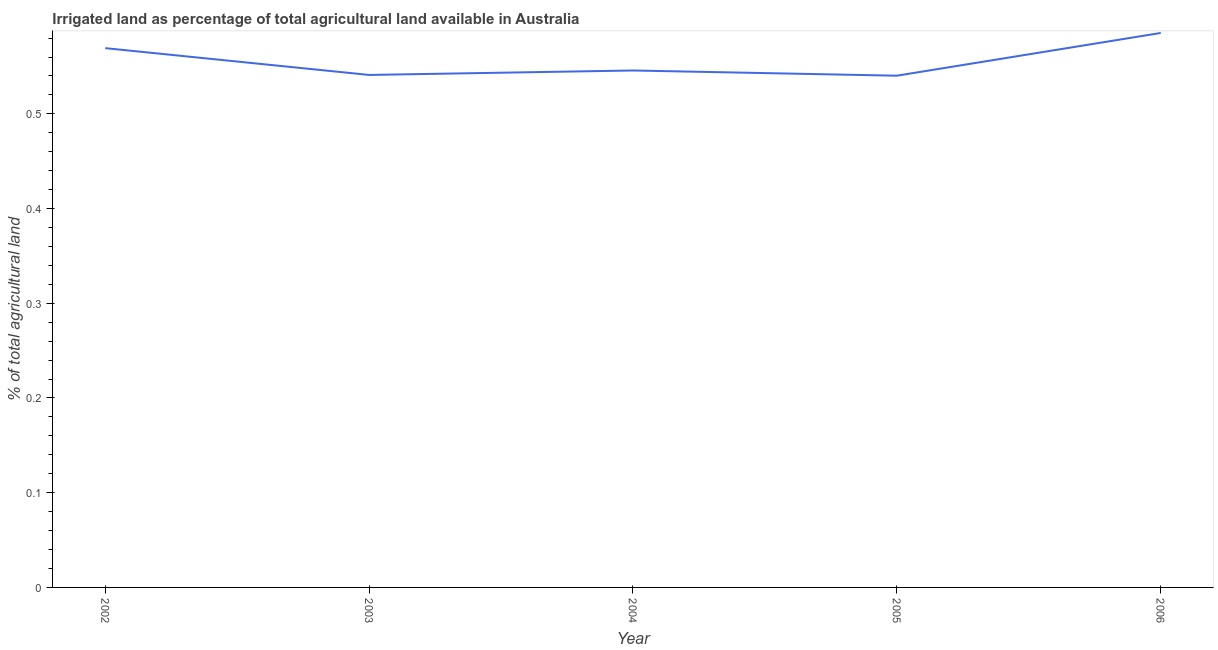What is the percentage of agricultural irrigated land in 2005?
Provide a short and direct response. 0.54. Across all years, what is the maximum percentage of agricultural irrigated land?
Keep it short and to the point. 0.59. Across all years, what is the minimum percentage of agricultural irrigated land?
Make the answer very short. 0.54. In which year was the percentage of agricultural irrigated land maximum?
Make the answer very short. 2006. What is the sum of the percentage of agricultural irrigated land?
Give a very brief answer. 2.78. What is the difference between the percentage of agricultural irrigated land in 2002 and 2005?
Offer a very short reply. 0.03. What is the average percentage of agricultural irrigated land per year?
Your response must be concise. 0.56. What is the median percentage of agricultural irrigated land?
Provide a short and direct response. 0.55. In how many years, is the percentage of agricultural irrigated land greater than 0.30000000000000004 %?
Your answer should be very brief. 5. Do a majority of the years between 2004 and 2002 (inclusive) have percentage of agricultural irrigated land greater than 0.06 %?
Your answer should be compact. No. What is the ratio of the percentage of agricultural irrigated land in 2003 to that in 2006?
Offer a terse response. 0.92. Is the difference between the percentage of agricultural irrigated land in 2005 and 2006 greater than the difference between any two years?
Keep it short and to the point. Yes. What is the difference between the highest and the second highest percentage of agricultural irrigated land?
Provide a short and direct response. 0.02. What is the difference between the highest and the lowest percentage of agricultural irrigated land?
Provide a succinct answer. 0.05. In how many years, is the percentage of agricultural irrigated land greater than the average percentage of agricultural irrigated land taken over all years?
Ensure brevity in your answer.  2. How many lines are there?
Offer a terse response. 1. Does the graph contain any zero values?
Your answer should be very brief. No. Does the graph contain grids?
Provide a succinct answer. No. What is the title of the graph?
Ensure brevity in your answer.  Irrigated land as percentage of total agricultural land available in Australia. What is the label or title of the Y-axis?
Provide a short and direct response. % of total agricultural land. What is the % of total agricultural land in 2002?
Your answer should be very brief. 0.57. What is the % of total agricultural land of 2003?
Give a very brief answer. 0.54. What is the % of total agricultural land of 2004?
Your answer should be very brief. 0.55. What is the % of total agricultural land of 2005?
Provide a short and direct response. 0.54. What is the % of total agricultural land of 2006?
Your answer should be very brief. 0.59. What is the difference between the % of total agricultural land in 2002 and 2003?
Offer a very short reply. 0.03. What is the difference between the % of total agricultural land in 2002 and 2004?
Give a very brief answer. 0.02. What is the difference between the % of total agricultural land in 2002 and 2005?
Your answer should be compact. 0.03. What is the difference between the % of total agricultural land in 2002 and 2006?
Your answer should be very brief. -0.02. What is the difference between the % of total agricultural land in 2003 and 2004?
Keep it short and to the point. -0. What is the difference between the % of total agricultural land in 2003 and 2005?
Ensure brevity in your answer.  0. What is the difference between the % of total agricultural land in 2003 and 2006?
Offer a terse response. -0.04. What is the difference between the % of total agricultural land in 2004 and 2005?
Provide a short and direct response. 0.01. What is the difference between the % of total agricultural land in 2004 and 2006?
Make the answer very short. -0.04. What is the difference between the % of total agricultural land in 2005 and 2006?
Provide a short and direct response. -0.05. What is the ratio of the % of total agricultural land in 2002 to that in 2003?
Your response must be concise. 1.05. What is the ratio of the % of total agricultural land in 2002 to that in 2004?
Your response must be concise. 1.04. What is the ratio of the % of total agricultural land in 2002 to that in 2005?
Provide a succinct answer. 1.05. What is the ratio of the % of total agricultural land in 2002 to that in 2006?
Offer a terse response. 0.97. What is the ratio of the % of total agricultural land in 2003 to that in 2006?
Give a very brief answer. 0.92. What is the ratio of the % of total agricultural land in 2004 to that in 2005?
Offer a very short reply. 1.01. What is the ratio of the % of total agricultural land in 2004 to that in 2006?
Offer a terse response. 0.93. What is the ratio of the % of total agricultural land in 2005 to that in 2006?
Offer a very short reply. 0.92. 